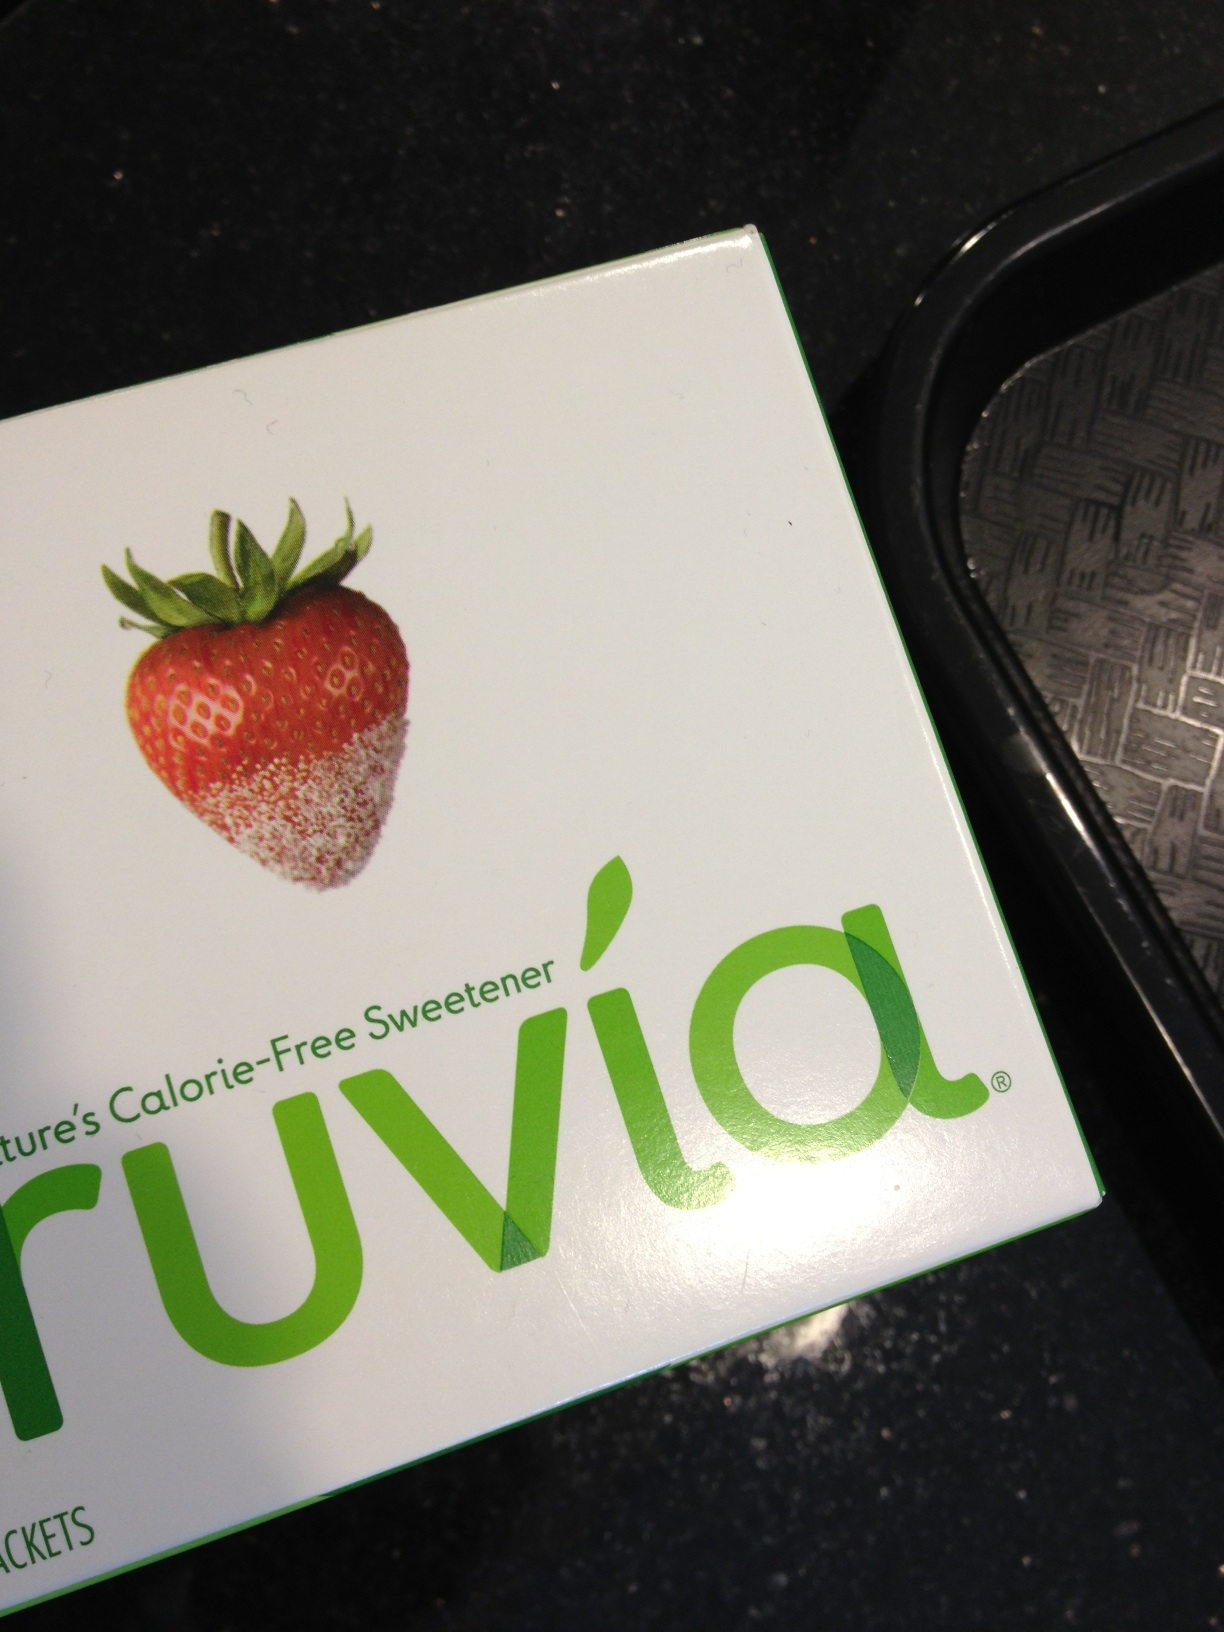this is a test. what is this? from Vizwiz The image depicts a box of Truvia, which is a brand of calorie-free sweetener made from stevia leaf extract, erythritol, and natural flavors. This product is commonly used as an alternative to sugar in various foods and beverages. 